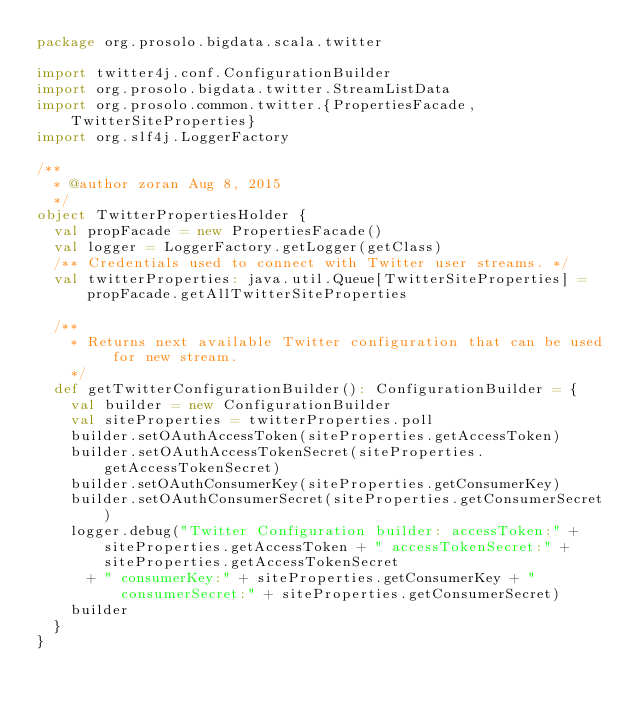<code> <loc_0><loc_0><loc_500><loc_500><_Scala_>package org.prosolo.bigdata.scala.twitter

import twitter4j.conf.ConfigurationBuilder
import org.prosolo.bigdata.twitter.StreamListData
import org.prosolo.common.twitter.{PropertiesFacade, TwitterSiteProperties}
import org.slf4j.LoggerFactory

/**
  * @author zoran Aug 8, 2015
  */
object TwitterPropertiesHolder {
  val propFacade = new PropertiesFacade()
  val logger = LoggerFactory.getLogger(getClass)
  /** Credentials used to connect with Twitter user streams. */
  val twitterProperties: java.util.Queue[TwitterSiteProperties] = propFacade.getAllTwitterSiteProperties

  /**
    * Returns next available Twitter configuration that can be used for new stream.
    */
  def getTwitterConfigurationBuilder(): ConfigurationBuilder = {
    val builder = new ConfigurationBuilder
    val siteProperties = twitterProperties.poll
    builder.setOAuthAccessToken(siteProperties.getAccessToken)
    builder.setOAuthAccessTokenSecret(siteProperties.getAccessTokenSecret)
    builder.setOAuthConsumerKey(siteProperties.getConsumerKey)
    builder.setOAuthConsumerSecret(siteProperties.getConsumerSecret)
    logger.debug("Twitter Configuration builder: accessToken:" + siteProperties.getAccessToken + " accessTokenSecret:" + siteProperties.getAccessTokenSecret
      + " consumerKey:" + siteProperties.getConsumerKey + " consumerSecret:" + siteProperties.getConsumerSecret)
    builder
  }
}</code> 